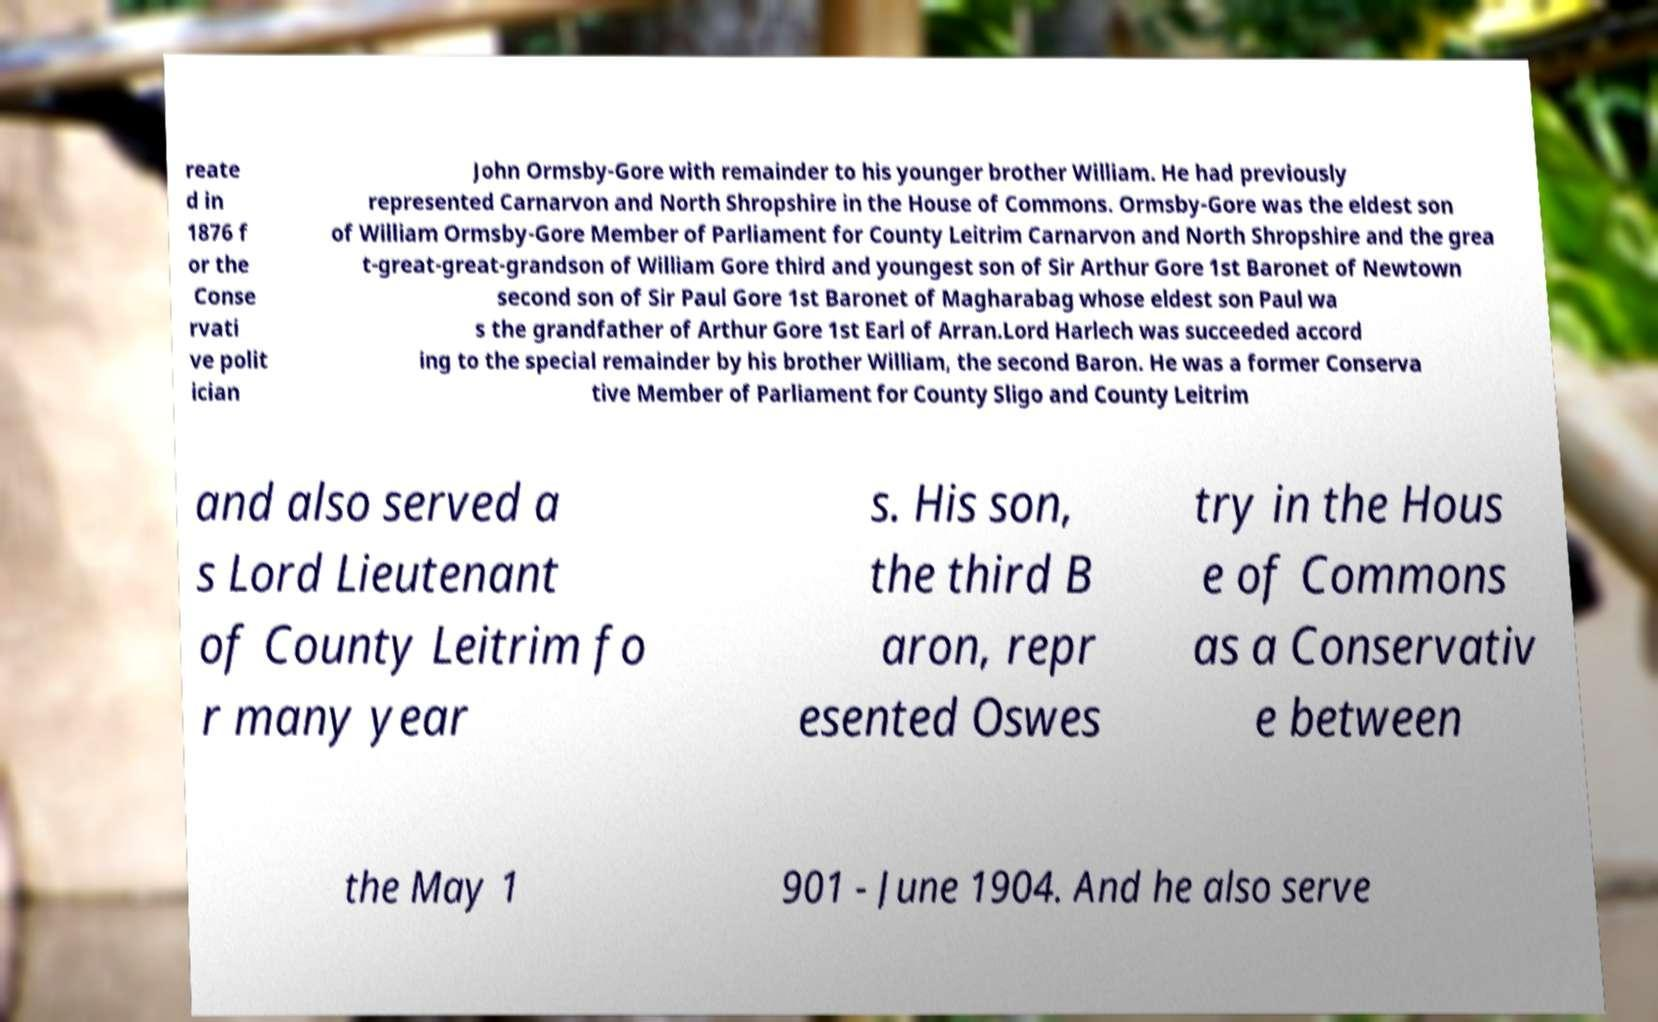Please read and relay the text visible in this image. What does it say? reate d in 1876 f or the Conse rvati ve polit ician John Ormsby-Gore with remainder to his younger brother William. He had previously represented Carnarvon and North Shropshire in the House of Commons. Ormsby-Gore was the eldest son of William Ormsby-Gore Member of Parliament for County Leitrim Carnarvon and North Shropshire and the grea t-great-great-grandson of William Gore third and youngest son of Sir Arthur Gore 1st Baronet of Newtown second son of Sir Paul Gore 1st Baronet of Magharabag whose eldest son Paul wa s the grandfather of Arthur Gore 1st Earl of Arran.Lord Harlech was succeeded accord ing to the special remainder by his brother William, the second Baron. He was a former Conserva tive Member of Parliament for County Sligo and County Leitrim and also served a s Lord Lieutenant of County Leitrim fo r many year s. His son, the third B aron, repr esented Oswes try in the Hous e of Commons as a Conservativ e between the May 1 901 - June 1904. And he also serve 